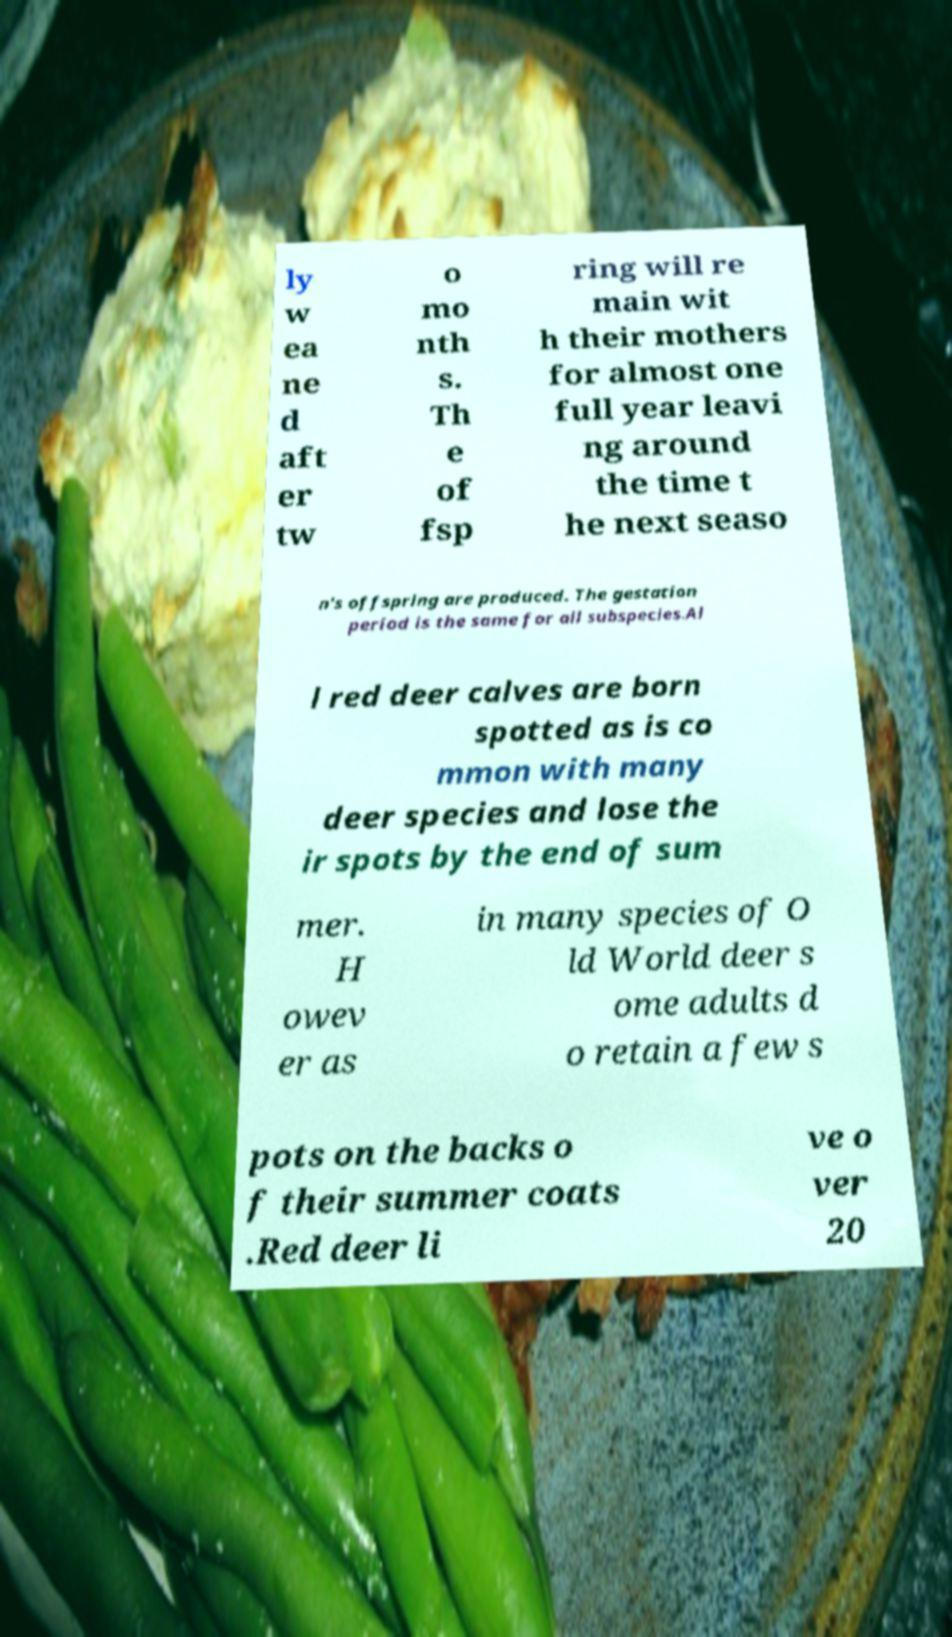Can you read and provide the text displayed in the image?This photo seems to have some interesting text. Can you extract and type it out for me? ly w ea ne d aft er tw o mo nth s. Th e of fsp ring will re main wit h their mothers for almost one full year leavi ng around the time t he next seaso n's offspring are produced. The gestation period is the same for all subspecies.Al l red deer calves are born spotted as is co mmon with many deer species and lose the ir spots by the end of sum mer. H owev er as in many species of O ld World deer s ome adults d o retain a few s pots on the backs o f their summer coats .Red deer li ve o ver 20 